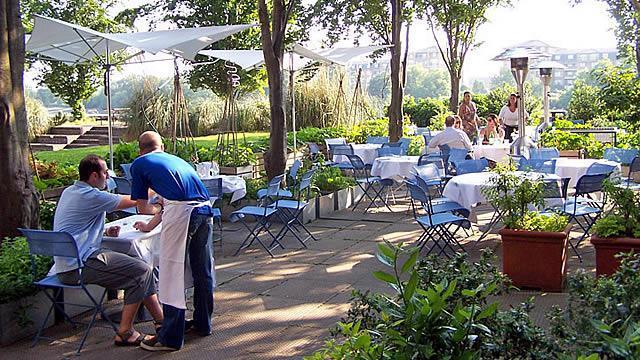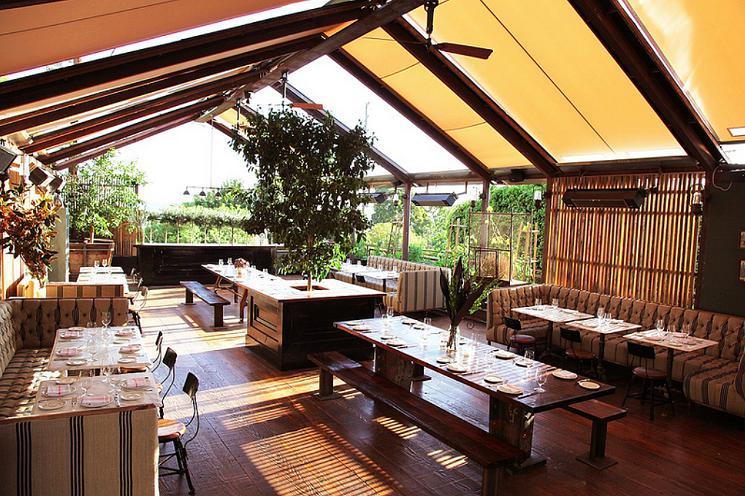The first image is the image on the left, the second image is the image on the right. Assess this claim about the two images: "Umbrellas are set up over a dining area in the image on the right.". Correct or not? Answer yes or no. No. 